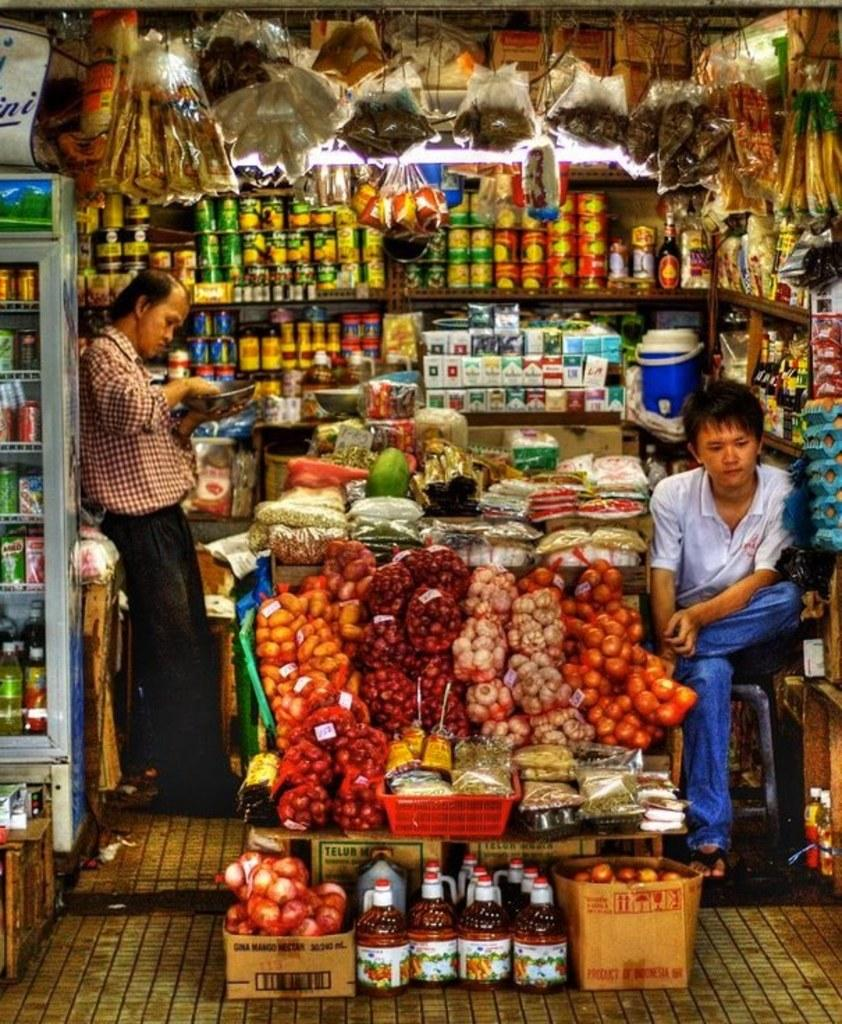What can be found in the shop according to the image? There are many objects in the shop. What type of items can be found in the fridge? There are beverages in the fridge. What is the location of the items hanging in the shop? The items hanging on the top. What is the man sitting on in the image? The man is sitting on a stool. What is the position of the other man in the shop? There is a man standing in the image. What type of song can be heard playing in the background of the image? There is no information about any song playing in the background of the image. 